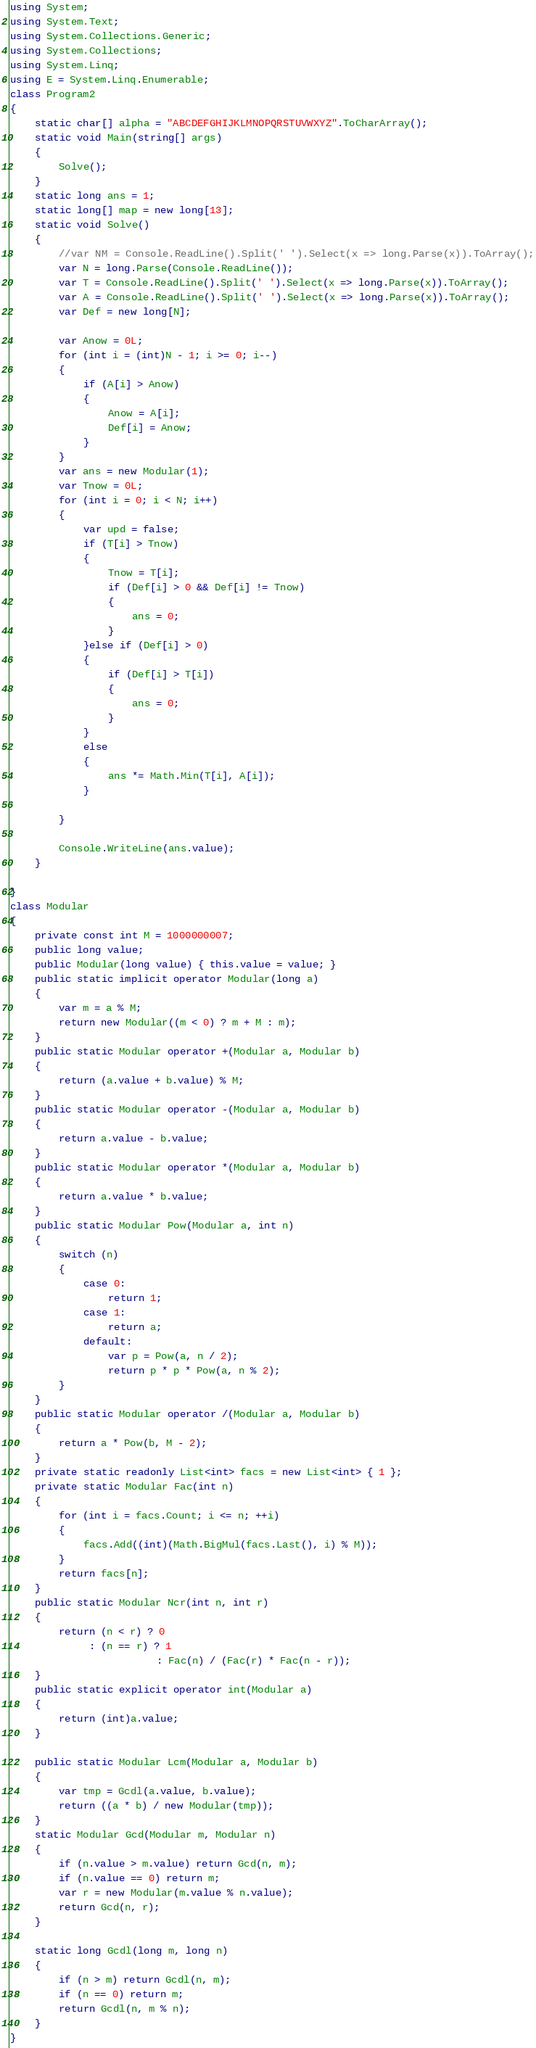Convert code to text. <code><loc_0><loc_0><loc_500><loc_500><_C#_>using System;
using System.Text;
using System.Collections.Generic;
using System.Collections;
using System.Linq;
using E = System.Linq.Enumerable;
class Program2
{
    static char[] alpha = "ABCDEFGHIJKLMNOPQRSTUVWXYZ".ToCharArray();
    static void Main(string[] args)
    {
        Solve();
    }
    static long ans = 1;
    static long[] map = new long[13];
    static void Solve()
    {
        //var NM = Console.ReadLine().Split(' ').Select(x => long.Parse(x)).ToArray();
        var N = long.Parse(Console.ReadLine());
        var T = Console.ReadLine().Split(' ').Select(x => long.Parse(x)).ToArray();
        var A = Console.ReadLine().Split(' ').Select(x => long.Parse(x)).ToArray();
        var Def = new long[N];

        var Anow = 0L;
        for (int i = (int)N - 1; i >= 0; i--)
        {
            if (A[i] > Anow)
            {
                Anow = A[i];
                Def[i] = Anow;
            }
        }
        var ans = new Modular(1);
        var Tnow = 0L;
        for (int i = 0; i < N; i++)
        {
            var upd = false;
            if (T[i] > Tnow)
            {
                Tnow = T[i];
                if (Def[i] > 0 && Def[i] != Tnow)
                {
                    ans = 0;
                }
            }else if (Def[i] > 0)
            {
                if (Def[i] > T[i])
                {
                    ans = 0;
                }
            }
            else
            {
                ans *= Math.Min(T[i], A[i]);
            }

        }

        Console.WriteLine(ans.value);
    }

}
class Modular
{
    private const int M = 1000000007;
    public long value;
    public Modular(long value) { this.value = value; }
    public static implicit operator Modular(long a)
    {
        var m = a % M;
        return new Modular((m < 0) ? m + M : m);
    }
    public static Modular operator +(Modular a, Modular b)
    {
        return (a.value + b.value) % M;
    }
    public static Modular operator -(Modular a, Modular b)
    {
        return a.value - b.value;
    }
    public static Modular operator *(Modular a, Modular b)
    {
        return a.value * b.value;
    }
    public static Modular Pow(Modular a, int n)
    {
        switch (n)
        {
            case 0:
                return 1;
            case 1:
                return a;
            default:
                var p = Pow(a, n / 2);
                return p * p * Pow(a, n % 2);
        }
    }
    public static Modular operator /(Modular a, Modular b)
    {
        return a * Pow(b, M - 2);
    }
    private static readonly List<int> facs = new List<int> { 1 };
    private static Modular Fac(int n)
    {
        for (int i = facs.Count; i <= n; ++i)
        {
            facs.Add((int)(Math.BigMul(facs.Last(), i) % M));
        }
        return facs[n];
    }
    public static Modular Ncr(int n, int r)
    {
        return (n < r) ? 0
             : (n == r) ? 1
                        : Fac(n) / (Fac(r) * Fac(n - r));
    }
    public static explicit operator int(Modular a)
    {
        return (int)a.value;
    }

    public static Modular Lcm(Modular a, Modular b)
    {
        var tmp = Gcdl(a.value, b.value);
        return ((a * b) / new Modular(tmp));
    }
    static Modular Gcd(Modular m, Modular n)
    {
        if (n.value > m.value) return Gcd(n, m);
        if (n.value == 0) return m;
        var r = new Modular(m.value % n.value);
        return Gcd(n, r);
    }

    static long Gcdl(long m, long n)
    {
        if (n > m) return Gcdl(n, m);
        if (n == 0) return m;
        return Gcdl(n, m % n);
    }
}

</code> 